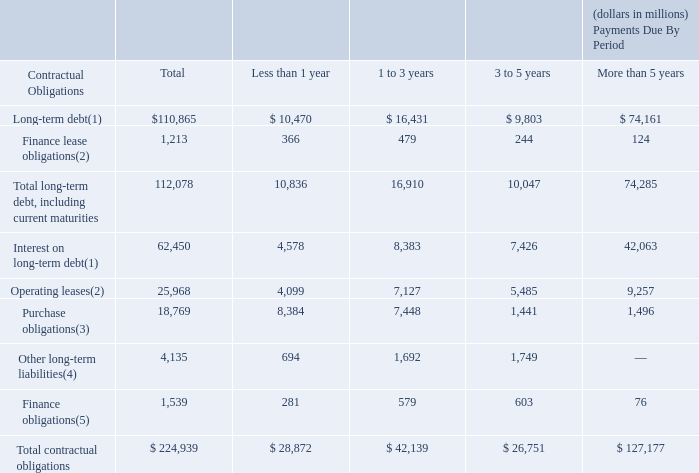Contractual Obligations
The following table provides a summary of our contractual obligations and commercial commitments at December 31, 2019. Additional detail about these items is included in the notes to the consolidated financial statements.
(1) Items included in long-term debt with variable coupon rates exclude unamortized debt issuance costs, and are described in Note 7 to the consolidated financial statements. (2) See Note 6 to the consolidated financial statements for additional information.
(3) Items included in purchase obligations are primarily commitments to purchase content and network services, equipment, software and marketing services, which will be used or sold in the ordinary course of business. These amounts do not represent our entire anticipated purchases in the future, but represent only those items that are the subject of contractual obligations. We also purchase products and services as needed with no firm commitment.
For this reason, the amounts presented in this table alone do not provide a reliable indicator of our expected future cash outflows or changes in our expected cash position. See Note 16 to the consolidated financial statements for additional information.
(4) Other long-term liabilities represent estimated postretirement benefit and qualified pension plan contributions. Estimated qualified pension plan contributions include expected minimum funding contributions, which commence in 2026 based on the plan’s current funded status. Estimated postretirement benefit payments include expected future postretirement benefit payments.
These estimated amounts: (1) are subject to change based on changes to assumptions and future plan performance, which could impact the timing or amounts of these payments; and (2) exclude expectations beyond 5 years due to uncertainty of the timing and amounts. See Note 11 to the consolidated financial statements for additional information.
(5) Represents future minimum payments under the sublease arrangement for our tower transaction. See Note 6 to the consolidated financial statements for additional information.
We are not able to make a reasonable estimate of when the unrecognized tax benefits balance of $2.9 billion and related interest and penalties will be settled with the respective taxing authorities until issues or examinations are further developed. See Note 12 to the consolidated financial statements for additional information.
What was the total long-term debt?
Answer scale should be: million. $110,865. What was the long-term debt less than 1 year?
Answer scale should be: million. $ 10,470. What was the total finance lease obligation?
Answer scale should be: million. 1,213. What is the difference between the long-term debt due less than 1 year and 1 to 3 years?
Answer scale should be: million. 16,431 - 10,470
Answer: 5961. What is the average long term debt payment for each payment period?
Answer scale should be: million. (10,470 + 16,431 + 9,803 + 74,161) / 4
Answer: 27716.25. What is the average finance lease obligation for each payment period?
Answer scale should be: million. (366 + 479 + 244 + 124) / 4
Answer: 303.25. 